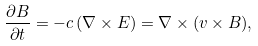<formula> <loc_0><loc_0><loc_500><loc_500>\frac { \partial B } { \partial t } = - c \, ( \nabla \times E ) = \nabla \times ( v \times B ) ,</formula> 